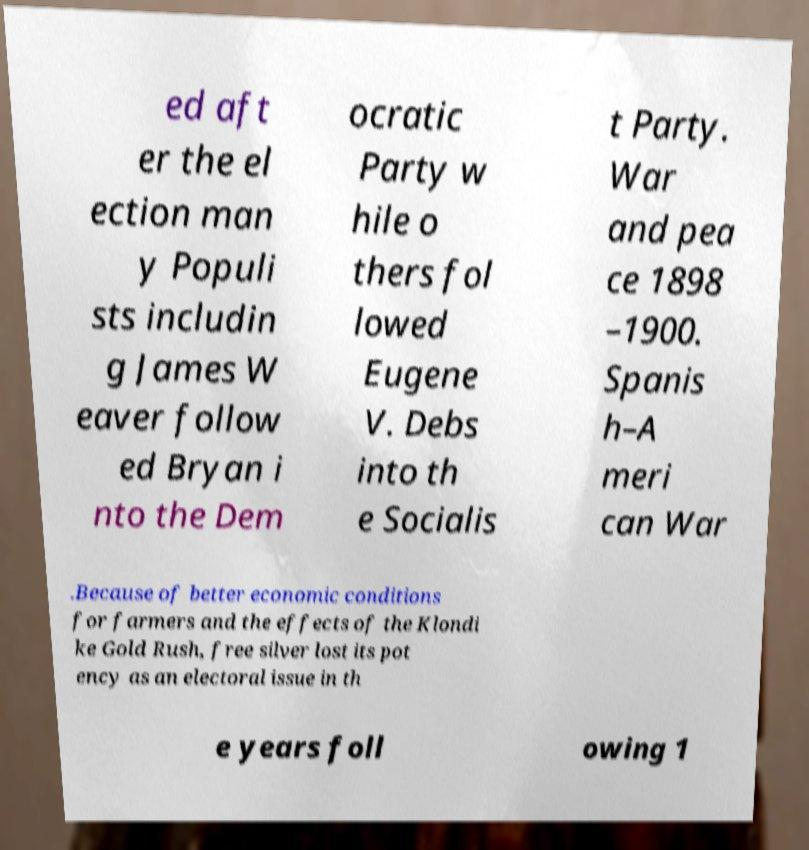What messages or text are displayed in this image? I need them in a readable, typed format. ed aft er the el ection man y Populi sts includin g James W eaver follow ed Bryan i nto the Dem ocratic Party w hile o thers fol lowed Eugene V. Debs into th e Socialis t Party. War and pea ce 1898 –1900. Spanis h–A meri can War .Because of better economic conditions for farmers and the effects of the Klondi ke Gold Rush, free silver lost its pot ency as an electoral issue in th e years foll owing 1 